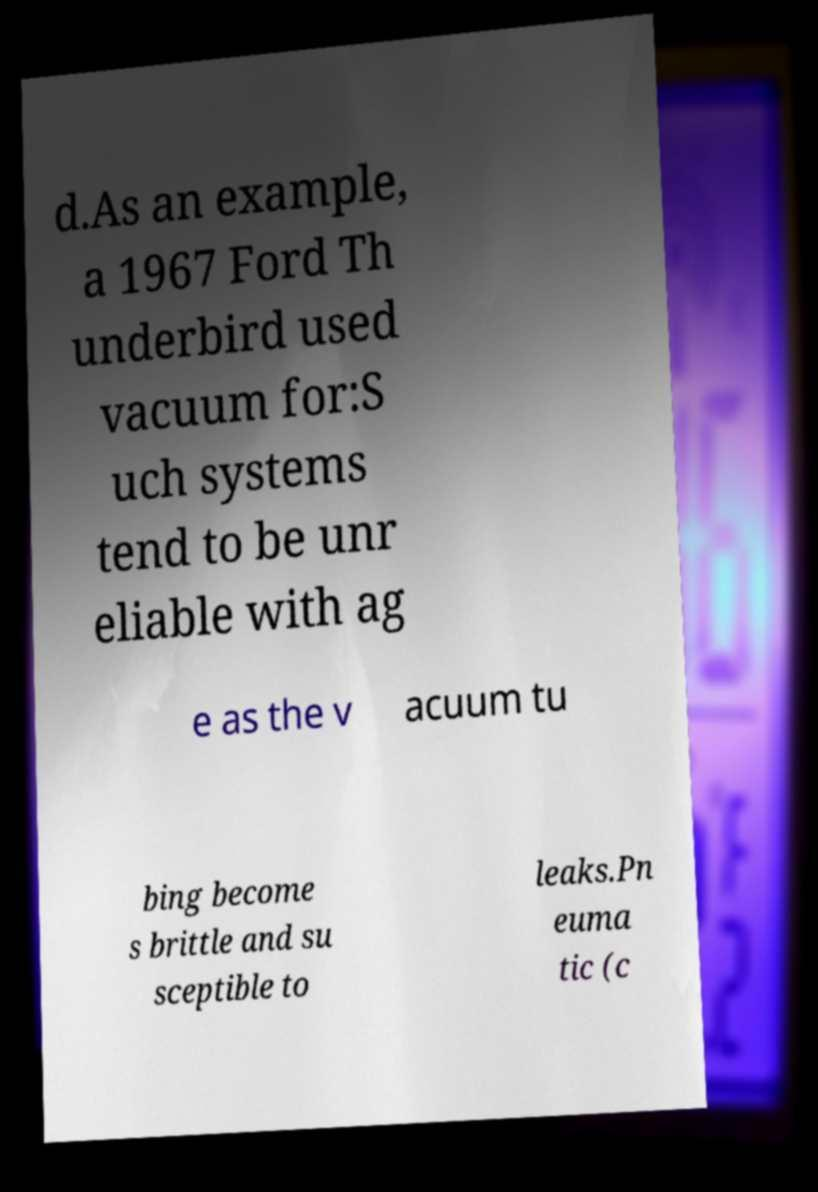Can you accurately transcribe the text from the provided image for me? d.As an example, a 1967 Ford Th underbird used vacuum for:S uch systems tend to be unr eliable with ag e as the v acuum tu bing become s brittle and su sceptible to leaks.Pn euma tic (c 